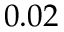Convert formula to latex. <formula><loc_0><loc_0><loc_500><loc_500>0 . 0 2</formula> 